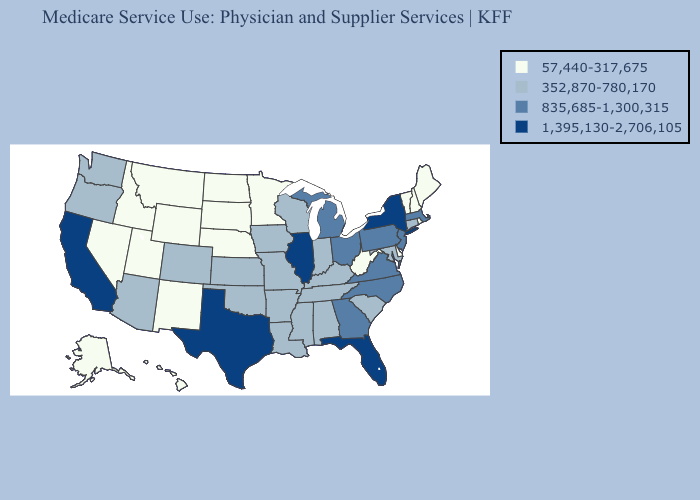Does Alabama have a lower value than North Carolina?
Write a very short answer. Yes. Does Illinois have the highest value in the USA?
Be succinct. Yes. Name the states that have a value in the range 57,440-317,675?
Give a very brief answer. Alaska, Delaware, Hawaii, Idaho, Maine, Minnesota, Montana, Nebraska, Nevada, New Hampshire, New Mexico, North Dakota, Rhode Island, South Dakota, Utah, Vermont, West Virginia, Wyoming. Among the states that border North Carolina , which have the highest value?
Keep it brief. Georgia, Virginia. What is the value of Mississippi?
Short answer required. 352,870-780,170. Is the legend a continuous bar?
Concise answer only. No. Does Mississippi have a higher value than Nebraska?
Short answer required. Yes. Name the states that have a value in the range 57,440-317,675?
Answer briefly. Alaska, Delaware, Hawaii, Idaho, Maine, Minnesota, Montana, Nebraska, Nevada, New Hampshire, New Mexico, North Dakota, Rhode Island, South Dakota, Utah, Vermont, West Virginia, Wyoming. Among the states that border Texas , does Arkansas have the highest value?
Write a very short answer. Yes. Name the states that have a value in the range 57,440-317,675?
Keep it brief. Alaska, Delaware, Hawaii, Idaho, Maine, Minnesota, Montana, Nebraska, Nevada, New Hampshire, New Mexico, North Dakota, Rhode Island, South Dakota, Utah, Vermont, West Virginia, Wyoming. Among the states that border Vermont , does New Hampshire have the lowest value?
Short answer required. Yes. Name the states that have a value in the range 1,395,130-2,706,105?
Write a very short answer. California, Florida, Illinois, New York, Texas. What is the value of Florida?
Be succinct. 1,395,130-2,706,105. Name the states that have a value in the range 57,440-317,675?
Be succinct. Alaska, Delaware, Hawaii, Idaho, Maine, Minnesota, Montana, Nebraska, Nevada, New Hampshire, New Mexico, North Dakota, Rhode Island, South Dakota, Utah, Vermont, West Virginia, Wyoming. Does Hawaii have the lowest value in the USA?
Write a very short answer. Yes. 